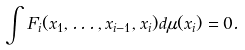<formula> <loc_0><loc_0><loc_500><loc_500>\int F _ { i } ( x _ { 1 } , \dots , x _ { i - 1 } , x _ { i } ) d \mu ( x _ { i } ) = 0 .</formula> 